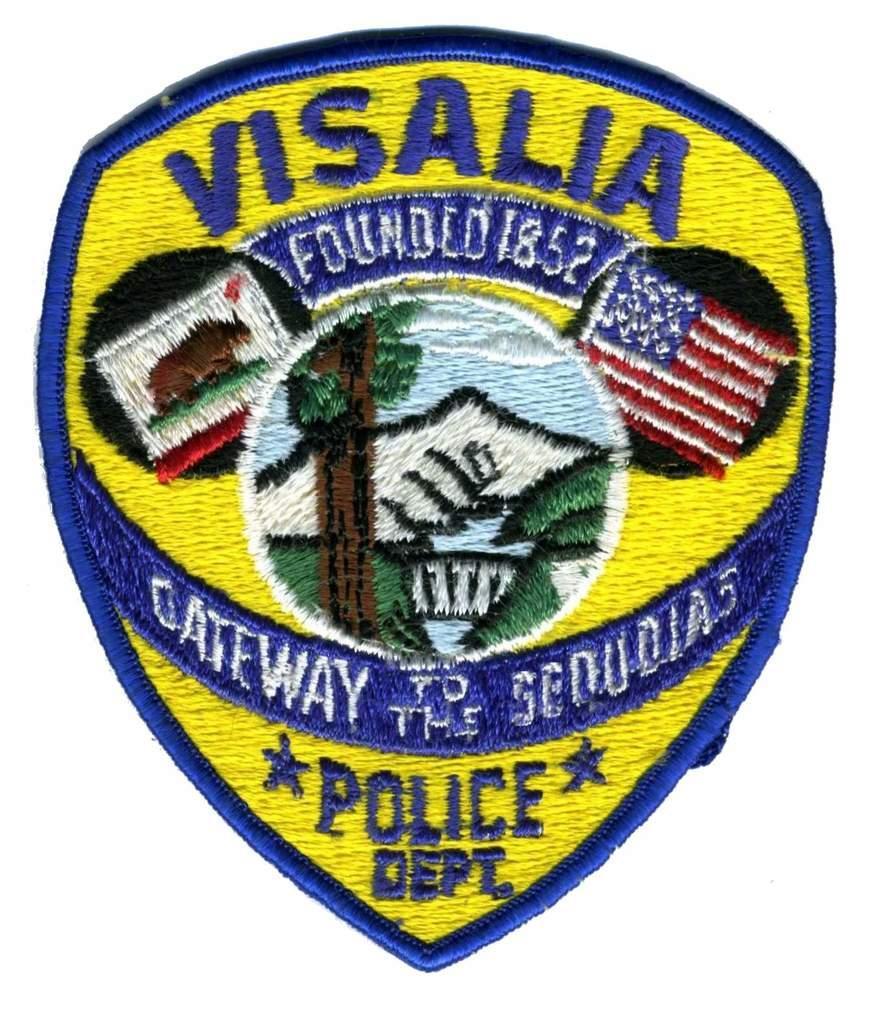Please provide a concise description of this image. In this image in the center there is one shield. 